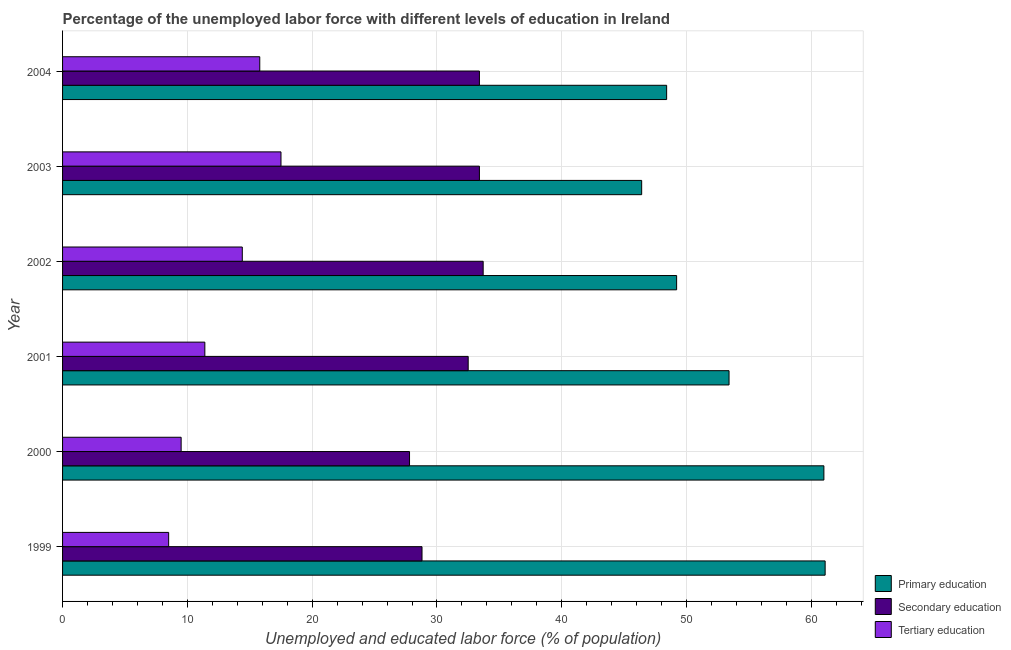How many different coloured bars are there?
Offer a terse response. 3. How many groups of bars are there?
Offer a very short reply. 6. How many bars are there on the 1st tick from the top?
Give a very brief answer. 3. What is the label of the 6th group of bars from the top?
Offer a terse response. 1999. What is the percentage of labor force who received secondary education in 2003?
Offer a terse response. 33.4. Across all years, what is the maximum percentage of labor force who received tertiary education?
Your answer should be compact. 17.5. Across all years, what is the minimum percentage of labor force who received secondary education?
Provide a short and direct response. 27.8. In which year was the percentage of labor force who received tertiary education minimum?
Your response must be concise. 1999. What is the total percentage of labor force who received secondary education in the graph?
Make the answer very short. 189.6. What is the difference between the percentage of labor force who received tertiary education in 2004 and the percentage of labor force who received primary education in 2001?
Provide a short and direct response. -37.6. What is the average percentage of labor force who received primary education per year?
Make the answer very short. 53.25. In the year 2003, what is the difference between the percentage of labor force who received tertiary education and percentage of labor force who received secondary education?
Keep it short and to the point. -15.9. Is the difference between the percentage of labor force who received secondary education in 2001 and 2003 greater than the difference between the percentage of labor force who received primary education in 2001 and 2003?
Your response must be concise. No. What is the difference between the highest and the second highest percentage of labor force who received secondary education?
Give a very brief answer. 0.3. In how many years, is the percentage of labor force who received tertiary education greater than the average percentage of labor force who received tertiary education taken over all years?
Give a very brief answer. 3. What does the 1st bar from the top in 2000 represents?
Your answer should be very brief. Tertiary education. How many bars are there?
Ensure brevity in your answer.  18. What is the difference between two consecutive major ticks on the X-axis?
Your answer should be very brief. 10. Does the graph contain any zero values?
Offer a very short reply. No. Does the graph contain grids?
Provide a short and direct response. Yes. What is the title of the graph?
Make the answer very short. Percentage of the unemployed labor force with different levels of education in Ireland. What is the label or title of the X-axis?
Provide a succinct answer. Unemployed and educated labor force (% of population). What is the Unemployed and educated labor force (% of population) in Primary education in 1999?
Give a very brief answer. 61.1. What is the Unemployed and educated labor force (% of population) of Secondary education in 1999?
Ensure brevity in your answer.  28.8. What is the Unemployed and educated labor force (% of population) in Tertiary education in 1999?
Provide a succinct answer. 8.5. What is the Unemployed and educated labor force (% of population) in Secondary education in 2000?
Offer a terse response. 27.8. What is the Unemployed and educated labor force (% of population) in Tertiary education in 2000?
Provide a succinct answer. 9.5. What is the Unemployed and educated labor force (% of population) of Primary education in 2001?
Offer a very short reply. 53.4. What is the Unemployed and educated labor force (% of population) in Secondary education in 2001?
Your answer should be compact. 32.5. What is the Unemployed and educated labor force (% of population) in Tertiary education in 2001?
Give a very brief answer. 11.4. What is the Unemployed and educated labor force (% of population) of Primary education in 2002?
Provide a succinct answer. 49.2. What is the Unemployed and educated labor force (% of population) of Secondary education in 2002?
Your answer should be very brief. 33.7. What is the Unemployed and educated labor force (% of population) of Tertiary education in 2002?
Provide a succinct answer. 14.4. What is the Unemployed and educated labor force (% of population) of Primary education in 2003?
Give a very brief answer. 46.4. What is the Unemployed and educated labor force (% of population) in Secondary education in 2003?
Your answer should be compact. 33.4. What is the Unemployed and educated labor force (% of population) in Tertiary education in 2003?
Your response must be concise. 17.5. What is the Unemployed and educated labor force (% of population) of Primary education in 2004?
Ensure brevity in your answer.  48.4. What is the Unemployed and educated labor force (% of population) in Secondary education in 2004?
Offer a terse response. 33.4. What is the Unemployed and educated labor force (% of population) of Tertiary education in 2004?
Provide a short and direct response. 15.8. Across all years, what is the maximum Unemployed and educated labor force (% of population) in Primary education?
Your response must be concise. 61.1. Across all years, what is the maximum Unemployed and educated labor force (% of population) in Secondary education?
Your answer should be very brief. 33.7. Across all years, what is the minimum Unemployed and educated labor force (% of population) in Primary education?
Offer a very short reply. 46.4. Across all years, what is the minimum Unemployed and educated labor force (% of population) in Secondary education?
Ensure brevity in your answer.  27.8. What is the total Unemployed and educated labor force (% of population) in Primary education in the graph?
Offer a very short reply. 319.5. What is the total Unemployed and educated labor force (% of population) of Secondary education in the graph?
Make the answer very short. 189.6. What is the total Unemployed and educated labor force (% of population) in Tertiary education in the graph?
Ensure brevity in your answer.  77.1. What is the difference between the Unemployed and educated labor force (% of population) in Secondary education in 1999 and that in 2000?
Keep it short and to the point. 1. What is the difference between the Unemployed and educated labor force (% of population) in Secondary education in 1999 and that in 2001?
Give a very brief answer. -3.7. What is the difference between the Unemployed and educated labor force (% of population) in Tertiary education in 1999 and that in 2001?
Make the answer very short. -2.9. What is the difference between the Unemployed and educated labor force (% of population) in Primary education in 1999 and that in 2002?
Give a very brief answer. 11.9. What is the difference between the Unemployed and educated labor force (% of population) of Tertiary education in 1999 and that in 2002?
Keep it short and to the point. -5.9. What is the difference between the Unemployed and educated labor force (% of population) of Primary education in 1999 and that in 2004?
Offer a very short reply. 12.7. What is the difference between the Unemployed and educated labor force (% of population) in Tertiary education in 1999 and that in 2004?
Your answer should be very brief. -7.3. What is the difference between the Unemployed and educated labor force (% of population) in Primary education in 2000 and that in 2001?
Your response must be concise. 7.6. What is the difference between the Unemployed and educated labor force (% of population) of Tertiary education in 2000 and that in 2001?
Your answer should be very brief. -1.9. What is the difference between the Unemployed and educated labor force (% of population) of Primary education in 2000 and that in 2002?
Provide a short and direct response. 11.8. What is the difference between the Unemployed and educated labor force (% of population) in Primary education in 2001 and that in 2003?
Your answer should be very brief. 7. What is the difference between the Unemployed and educated labor force (% of population) in Secondary education in 2001 and that in 2003?
Offer a very short reply. -0.9. What is the difference between the Unemployed and educated labor force (% of population) in Secondary education in 2002 and that in 2003?
Your answer should be compact. 0.3. What is the difference between the Unemployed and educated labor force (% of population) in Secondary education in 2002 and that in 2004?
Offer a terse response. 0.3. What is the difference between the Unemployed and educated labor force (% of population) of Tertiary education in 2002 and that in 2004?
Your answer should be compact. -1.4. What is the difference between the Unemployed and educated labor force (% of population) of Primary education in 2003 and that in 2004?
Offer a terse response. -2. What is the difference between the Unemployed and educated labor force (% of population) of Tertiary education in 2003 and that in 2004?
Keep it short and to the point. 1.7. What is the difference between the Unemployed and educated labor force (% of population) in Primary education in 1999 and the Unemployed and educated labor force (% of population) in Secondary education in 2000?
Your response must be concise. 33.3. What is the difference between the Unemployed and educated labor force (% of population) in Primary education in 1999 and the Unemployed and educated labor force (% of population) in Tertiary education in 2000?
Your answer should be very brief. 51.6. What is the difference between the Unemployed and educated labor force (% of population) of Secondary education in 1999 and the Unemployed and educated labor force (% of population) of Tertiary education in 2000?
Give a very brief answer. 19.3. What is the difference between the Unemployed and educated labor force (% of population) in Primary education in 1999 and the Unemployed and educated labor force (% of population) in Secondary education in 2001?
Offer a very short reply. 28.6. What is the difference between the Unemployed and educated labor force (% of population) in Primary education in 1999 and the Unemployed and educated labor force (% of population) in Tertiary education in 2001?
Provide a succinct answer. 49.7. What is the difference between the Unemployed and educated labor force (% of population) in Primary education in 1999 and the Unemployed and educated labor force (% of population) in Secondary education in 2002?
Offer a terse response. 27.4. What is the difference between the Unemployed and educated labor force (% of population) of Primary education in 1999 and the Unemployed and educated labor force (% of population) of Tertiary education in 2002?
Offer a terse response. 46.7. What is the difference between the Unemployed and educated labor force (% of population) of Primary education in 1999 and the Unemployed and educated labor force (% of population) of Secondary education in 2003?
Offer a terse response. 27.7. What is the difference between the Unemployed and educated labor force (% of population) of Primary education in 1999 and the Unemployed and educated labor force (% of population) of Tertiary education in 2003?
Your answer should be compact. 43.6. What is the difference between the Unemployed and educated labor force (% of population) of Primary education in 1999 and the Unemployed and educated labor force (% of population) of Secondary education in 2004?
Keep it short and to the point. 27.7. What is the difference between the Unemployed and educated labor force (% of population) of Primary education in 1999 and the Unemployed and educated labor force (% of population) of Tertiary education in 2004?
Give a very brief answer. 45.3. What is the difference between the Unemployed and educated labor force (% of population) of Primary education in 2000 and the Unemployed and educated labor force (% of population) of Secondary education in 2001?
Your response must be concise. 28.5. What is the difference between the Unemployed and educated labor force (% of population) of Primary education in 2000 and the Unemployed and educated labor force (% of population) of Tertiary education in 2001?
Offer a very short reply. 49.6. What is the difference between the Unemployed and educated labor force (% of population) of Primary education in 2000 and the Unemployed and educated labor force (% of population) of Secondary education in 2002?
Your response must be concise. 27.3. What is the difference between the Unemployed and educated labor force (% of population) in Primary education in 2000 and the Unemployed and educated labor force (% of population) in Tertiary education in 2002?
Give a very brief answer. 46.6. What is the difference between the Unemployed and educated labor force (% of population) in Primary education in 2000 and the Unemployed and educated labor force (% of population) in Secondary education in 2003?
Your answer should be very brief. 27.6. What is the difference between the Unemployed and educated labor force (% of population) of Primary education in 2000 and the Unemployed and educated labor force (% of population) of Tertiary education in 2003?
Offer a very short reply. 43.5. What is the difference between the Unemployed and educated labor force (% of population) in Secondary education in 2000 and the Unemployed and educated labor force (% of population) in Tertiary education in 2003?
Give a very brief answer. 10.3. What is the difference between the Unemployed and educated labor force (% of population) in Primary education in 2000 and the Unemployed and educated labor force (% of population) in Secondary education in 2004?
Your answer should be very brief. 27.6. What is the difference between the Unemployed and educated labor force (% of population) in Primary education in 2000 and the Unemployed and educated labor force (% of population) in Tertiary education in 2004?
Ensure brevity in your answer.  45.2. What is the difference between the Unemployed and educated labor force (% of population) in Secondary education in 2000 and the Unemployed and educated labor force (% of population) in Tertiary education in 2004?
Your response must be concise. 12. What is the difference between the Unemployed and educated labor force (% of population) in Primary education in 2001 and the Unemployed and educated labor force (% of population) in Secondary education in 2002?
Offer a terse response. 19.7. What is the difference between the Unemployed and educated labor force (% of population) in Primary education in 2001 and the Unemployed and educated labor force (% of population) in Tertiary education in 2002?
Ensure brevity in your answer.  39. What is the difference between the Unemployed and educated labor force (% of population) in Secondary education in 2001 and the Unemployed and educated labor force (% of population) in Tertiary education in 2002?
Provide a short and direct response. 18.1. What is the difference between the Unemployed and educated labor force (% of population) of Primary education in 2001 and the Unemployed and educated labor force (% of population) of Secondary education in 2003?
Keep it short and to the point. 20. What is the difference between the Unemployed and educated labor force (% of population) in Primary education in 2001 and the Unemployed and educated labor force (% of population) in Tertiary education in 2003?
Keep it short and to the point. 35.9. What is the difference between the Unemployed and educated labor force (% of population) in Primary education in 2001 and the Unemployed and educated labor force (% of population) in Secondary education in 2004?
Your response must be concise. 20. What is the difference between the Unemployed and educated labor force (% of population) in Primary education in 2001 and the Unemployed and educated labor force (% of population) in Tertiary education in 2004?
Your answer should be compact. 37.6. What is the difference between the Unemployed and educated labor force (% of population) of Secondary education in 2001 and the Unemployed and educated labor force (% of population) of Tertiary education in 2004?
Make the answer very short. 16.7. What is the difference between the Unemployed and educated labor force (% of population) in Primary education in 2002 and the Unemployed and educated labor force (% of population) in Tertiary education in 2003?
Make the answer very short. 31.7. What is the difference between the Unemployed and educated labor force (% of population) of Secondary education in 2002 and the Unemployed and educated labor force (% of population) of Tertiary education in 2003?
Make the answer very short. 16.2. What is the difference between the Unemployed and educated labor force (% of population) in Primary education in 2002 and the Unemployed and educated labor force (% of population) in Tertiary education in 2004?
Offer a terse response. 33.4. What is the difference between the Unemployed and educated labor force (% of population) of Primary education in 2003 and the Unemployed and educated labor force (% of population) of Tertiary education in 2004?
Give a very brief answer. 30.6. What is the average Unemployed and educated labor force (% of population) of Primary education per year?
Make the answer very short. 53.25. What is the average Unemployed and educated labor force (% of population) in Secondary education per year?
Make the answer very short. 31.6. What is the average Unemployed and educated labor force (% of population) in Tertiary education per year?
Your answer should be very brief. 12.85. In the year 1999, what is the difference between the Unemployed and educated labor force (% of population) of Primary education and Unemployed and educated labor force (% of population) of Secondary education?
Provide a succinct answer. 32.3. In the year 1999, what is the difference between the Unemployed and educated labor force (% of population) of Primary education and Unemployed and educated labor force (% of population) of Tertiary education?
Keep it short and to the point. 52.6. In the year 1999, what is the difference between the Unemployed and educated labor force (% of population) of Secondary education and Unemployed and educated labor force (% of population) of Tertiary education?
Provide a short and direct response. 20.3. In the year 2000, what is the difference between the Unemployed and educated labor force (% of population) of Primary education and Unemployed and educated labor force (% of population) of Secondary education?
Provide a short and direct response. 33.2. In the year 2000, what is the difference between the Unemployed and educated labor force (% of population) of Primary education and Unemployed and educated labor force (% of population) of Tertiary education?
Keep it short and to the point. 51.5. In the year 2001, what is the difference between the Unemployed and educated labor force (% of population) of Primary education and Unemployed and educated labor force (% of population) of Secondary education?
Provide a short and direct response. 20.9. In the year 2001, what is the difference between the Unemployed and educated labor force (% of population) of Secondary education and Unemployed and educated labor force (% of population) of Tertiary education?
Give a very brief answer. 21.1. In the year 2002, what is the difference between the Unemployed and educated labor force (% of population) in Primary education and Unemployed and educated labor force (% of population) in Tertiary education?
Keep it short and to the point. 34.8. In the year 2002, what is the difference between the Unemployed and educated labor force (% of population) in Secondary education and Unemployed and educated labor force (% of population) in Tertiary education?
Make the answer very short. 19.3. In the year 2003, what is the difference between the Unemployed and educated labor force (% of population) in Primary education and Unemployed and educated labor force (% of population) in Secondary education?
Your answer should be very brief. 13. In the year 2003, what is the difference between the Unemployed and educated labor force (% of population) in Primary education and Unemployed and educated labor force (% of population) in Tertiary education?
Your answer should be very brief. 28.9. In the year 2004, what is the difference between the Unemployed and educated labor force (% of population) of Primary education and Unemployed and educated labor force (% of population) of Tertiary education?
Your answer should be very brief. 32.6. What is the ratio of the Unemployed and educated labor force (% of population) in Primary education in 1999 to that in 2000?
Your response must be concise. 1. What is the ratio of the Unemployed and educated labor force (% of population) of Secondary education in 1999 to that in 2000?
Offer a terse response. 1.04. What is the ratio of the Unemployed and educated labor force (% of population) of Tertiary education in 1999 to that in 2000?
Your response must be concise. 0.89. What is the ratio of the Unemployed and educated labor force (% of population) in Primary education in 1999 to that in 2001?
Make the answer very short. 1.14. What is the ratio of the Unemployed and educated labor force (% of population) of Secondary education in 1999 to that in 2001?
Provide a short and direct response. 0.89. What is the ratio of the Unemployed and educated labor force (% of population) in Tertiary education in 1999 to that in 2001?
Provide a succinct answer. 0.75. What is the ratio of the Unemployed and educated labor force (% of population) in Primary education in 1999 to that in 2002?
Offer a very short reply. 1.24. What is the ratio of the Unemployed and educated labor force (% of population) of Secondary education in 1999 to that in 2002?
Offer a very short reply. 0.85. What is the ratio of the Unemployed and educated labor force (% of population) in Tertiary education in 1999 to that in 2002?
Give a very brief answer. 0.59. What is the ratio of the Unemployed and educated labor force (% of population) of Primary education in 1999 to that in 2003?
Make the answer very short. 1.32. What is the ratio of the Unemployed and educated labor force (% of population) of Secondary education in 1999 to that in 2003?
Offer a terse response. 0.86. What is the ratio of the Unemployed and educated labor force (% of population) in Tertiary education in 1999 to that in 2003?
Keep it short and to the point. 0.49. What is the ratio of the Unemployed and educated labor force (% of population) in Primary education in 1999 to that in 2004?
Provide a succinct answer. 1.26. What is the ratio of the Unemployed and educated labor force (% of population) in Secondary education in 1999 to that in 2004?
Provide a short and direct response. 0.86. What is the ratio of the Unemployed and educated labor force (% of population) in Tertiary education in 1999 to that in 2004?
Ensure brevity in your answer.  0.54. What is the ratio of the Unemployed and educated labor force (% of population) of Primary education in 2000 to that in 2001?
Make the answer very short. 1.14. What is the ratio of the Unemployed and educated labor force (% of population) of Secondary education in 2000 to that in 2001?
Give a very brief answer. 0.86. What is the ratio of the Unemployed and educated labor force (% of population) in Primary education in 2000 to that in 2002?
Ensure brevity in your answer.  1.24. What is the ratio of the Unemployed and educated labor force (% of population) in Secondary education in 2000 to that in 2002?
Keep it short and to the point. 0.82. What is the ratio of the Unemployed and educated labor force (% of population) of Tertiary education in 2000 to that in 2002?
Your answer should be compact. 0.66. What is the ratio of the Unemployed and educated labor force (% of population) in Primary education in 2000 to that in 2003?
Provide a succinct answer. 1.31. What is the ratio of the Unemployed and educated labor force (% of population) in Secondary education in 2000 to that in 2003?
Ensure brevity in your answer.  0.83. What is the ratio of the Unemployed and educated labor force (% of population) of Tertiary education in 2000 to that in 2003?
Make the answer very short. 0.54. What is the ratio of the Unemployed and educated labor force (% of population) in Primary education in 2000 to that in 2004?
Your answer should be compact. 1.26. What is the ratio of the Unemployed and educated labor force (% of population) of Secondary education in 2000 to that in 2004?
Provide a succinct answer. 0.83. What is the ratio of the Unemployed and educated labor force (% of population) in Tertiary education in 2000 to that in 2004?
Make the answer very short. 0.6. What is the ratio of the Unemployed and educated labor force (% of population) in Primary education in 2001 to that in 2002?
Provide a short and direct response. 1.09. What is the ratio of the Unemployed and educated labor force (% of population) of Secondary education in 2001 to that in 2002?
Your response must be concise. 0.96. What is the ratio of the Unemployed and educated labor force (% of population) of Tertiary education in 2001 to that in 2002?
Offer a terse response. 0.79. What is the ratio of the Unemployed and educated labor force (% of population) in Primary education in 2001 to that in 2003?
Keep it short and to the point. 1.15. What is the ratio of the Unemployed and educated labor force (% of population) in Secondary education in 2001 to that in 2003?
Offer a terse response. 0.97. What is the ratio of the Unemployed and educated labor force (% of population) in Tertiary education in 2001 to that in 2003?
Give a very brief answer. 0.65. What is the ratio of the Unemployed and educated labor force (% of population) of Primary education in 2001 to that in 2004?
Your answer should be very brief. 1.1. What is the ratio of the Unemployed and educated labor force (% of population) of Secondary education in 2001 to that in 2004?
Your response must be concise. 0.97. What is the ratio of the Unemployed and educated labor force (% of population) in Tertiary education in 2001 to that in 2004?
Ensure brevity in your answer.  0.72. What is the ratio of the Unemployed and educated labor force (% of population) of Primary education in 2002 to that in 2003?
Make the answer very short. 1.06. What is the ratio of the Unemployed and educated labor force (% of population) in Tertiary education in 2002 to that in 2003?
Give a very brief answer. 0.82. What is the ratio of the Unemployed and educated labor force (% of population) in Primary education in 2002 to that in 2004?
Keep it short and to the point. 1.02. What is the ratio of the Unemployed and educated labor force (% of population) in Tertiary education in 2002 to that in 2004?
Provide a succinct answer. 0.91. What is the ratio of the Unemployed and educated labor force (% of population) in Primary education in 2003 to that in 2004?
Your response must be concise. 0.96. What is the ratio of the Unemployed and educated labor force (% of population) of Secondary education in 2003 to that in 2004?
Make the answer very short. 1. What is the ratio of the Unemployed and educated labor force (% of population) of Tertiary education in 2003 to that in 2004?
Make the answer very short. 1.11. What is the difference between the highest and the second highest Unemployed and educated labor force (% of population) of Primary education?
Your answer should be very brief. 0.1. What is the difference between the highest and the second highest Unemployed and educated labor force (% of population) of Secondary education?
Your answer should be very brief. 0.3. What is the difference between the highest and the lowest Unemployed and educated labor force (% of population) of Secondary education?
Provide a succinct answer. 5.9. What is the difference between the highest and the lowest Unemployed and educated labor force (% of population) of Tertiary education?
Give a very brief answer. 9. 